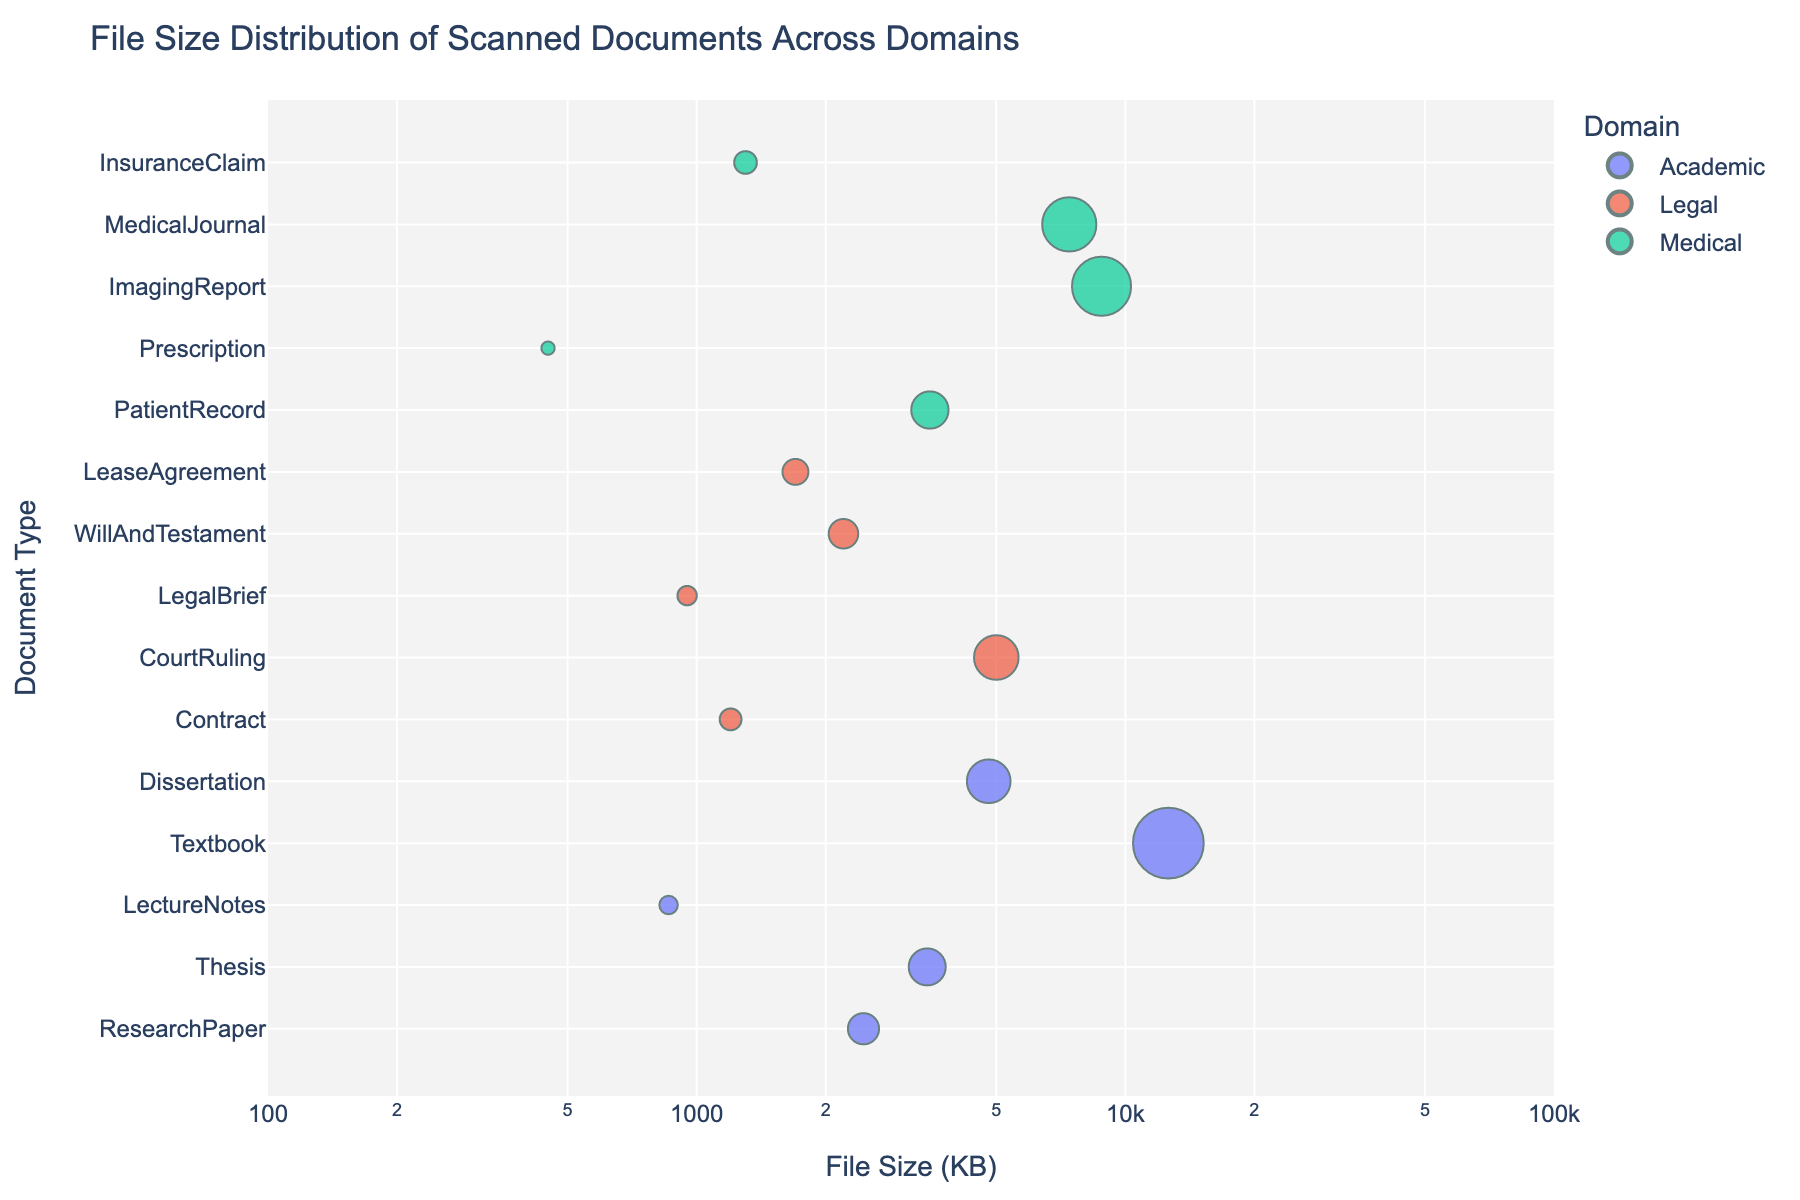What's the title of the figure? The title is visible at the top of the figure and is straightforward to read.
Answer: File Size Distribution of Scanned Documents Across Domains What are the three domains represented in the scatter plot? The domains are indicated by the different colors in the legend to the right or bottom of the figure.
Answer: Academic, Legal, Medical Which document type has the largest file size and belongs to the Academic domain? By looking at the plot along the x-axis and identifying the point with the largest file size within the Academic domain, we can determine the document type.
Answer: Textbook How many distinct document types are listed in the Medical domain? By counting the unique document type values associated with the Medical domain color, we find the number of distinct types.
Answer: 5 What's the smallest file size among the documents in the Legal domain? Locate the point in the Legal domain with the smallest x-axis value to determine the smallest file size.
Answer: 950 KB How does the average file size of Academic documents compare to Medical documents? Calculate the average file size for each domain and compare them: (2450+3450+860+12600+4800)/5 for Academic and (3500+450+8800+7400+1300)/5 for Medical.
Answer: Academic's average is larger Which document type within the Medical domain has the largest file size? Look for the point with the highest x-value within the Medical domain color to find the document type.
Answer: ImagingReport Is there any document type with a file size smaller than 1000 KB? If yes, list them. Identify points on the scatter plot with x-values less than 1000 KB and list the corresponding document types.
Answer: LectureNotes, LegalBrief, Prescription Compare the file size of 'Contracts' in the Legal domain to 'Thesis' documents in the Academic domain. Which is bigger? Locate the points for 'Contracts' and 'Thesis' and compare their x-axis values to see which is larger.
Answer: Thesis What is the approximate file size range of documents in the Academic domain? Identify the smallest and largest x-axis values within the Academic domain color to determine the range.
Answer: 860 KB to 12600 KB 